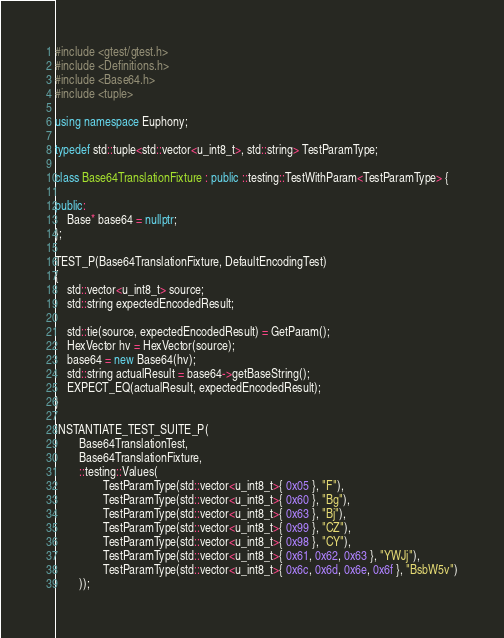<code> <loc_0><loc_0><loc_500><loc_500><_C++_>#include <gtest/gtest.h>
#include <Definitions.h>
#include <Base64.h>
#include <tuple>

using namespace Euphony;

typedef std::tuple<std::vector<u_int8_t>, std::string> TestParamType;

class Base64TranslationFixture : public ::testing::TestWithParam<TestParamType> {

public:
    Base* base64 = nullptr;
};

TEST_P(Base64TranslationFixture, DefaultEncodingTest)
{
    std::vector<u_int8_t> source;
    std::string expectedEncodedResult;

    std::tie(source, expectedEncodedResult) = GetParam();
    HexVector hv = HexVector(source);
    base64 = new Base64(hv);
    std::string actualResult = base64->getBaseString();
    EXPECT_EQ(actualResult, expectedEncodedResult);
}

INSTANTIATE_TEST_SUITE_P(
        Base64TranslationTest,
        Base64TranslationFixture,
        ::testing::Values(
                TestParamType(std::vector<u_int8_t>{ 0x05 }, "F"),
                TestParamType(std::vector<u_int8_t>{ 0x60 }, "Bg"),
                TestParamType(std::vector<u_int8_t>{ 0x63 }, "Bj"),
                TestParamType(std::vector<u_int8_t>{ 0x99 }, "CZ"),
                TestParamType(std::vector<u_int8_t>{ 0x98 }, "CY"),
                TestParamType(std::vector<u_int8_t>{ 0x61, 0x62, 0x63 }, "YWJj"),
                TestParamType(std::vector<u_int8_t>{ 0x6c, 0x6d, 0x6e, 0x6f }, "BsbW5v")
        ));</code> 